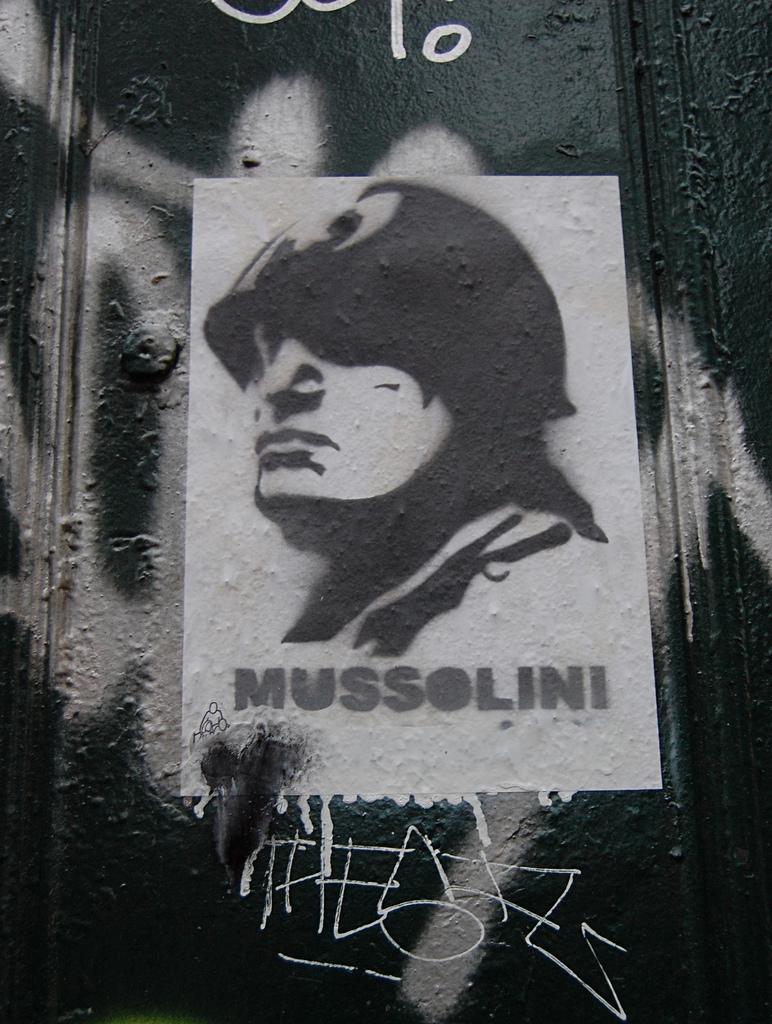Describe this image in one or two sentences. This is a black and white picture. In this picture, we see the poster of the man is pasted on the wall. In the background, we see a wall. We see some text written on the wall. 